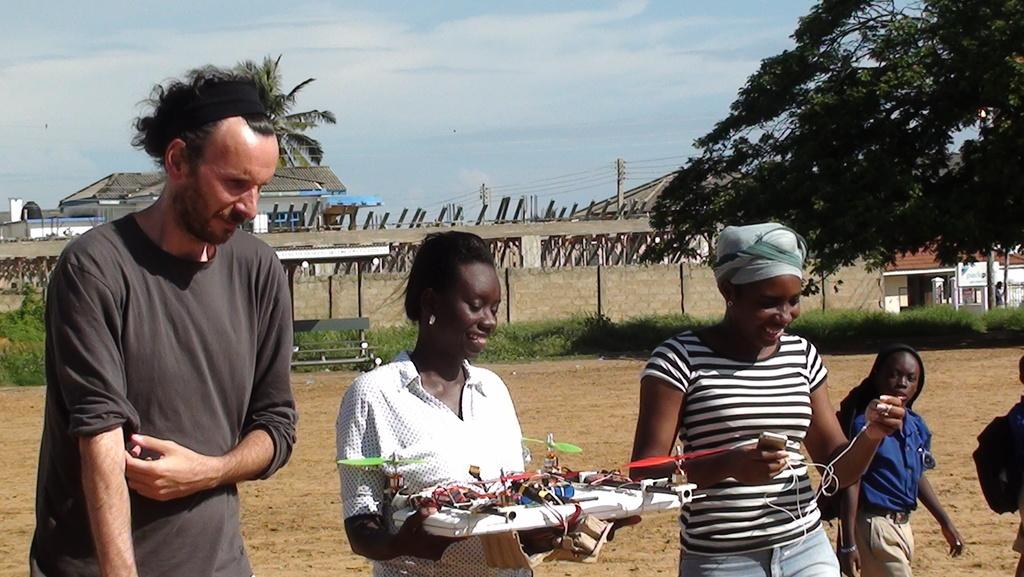How many people are in the image? There are people in the image, but the exact number is not specified. What is one person holding in the image? One person is holding something, but the specific object is not mentioned. What type of structures can be seen in the image? There are houses in the image. What type of vegetation is present in the image? There are trees and plants in the image. Can you describe any other elements in the image? There are other unspecified things in the image. What type of hole can be seen in the image? There is no hole present in the image. What type of quartz can be seen in the image? There is no quartz present in the image. 